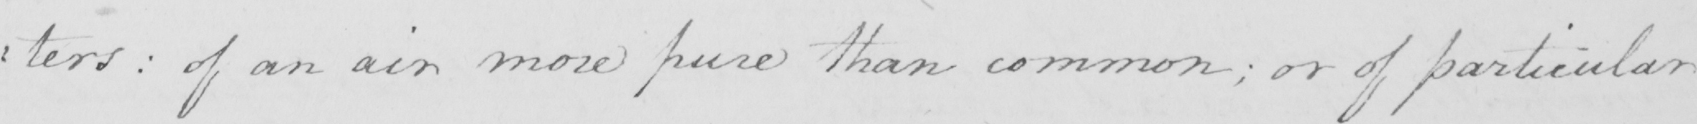Transcribe the text shown in this historical manuscript line. : ters :  of an air more pure than common ; or of particular 